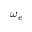Convert formula to latex. <formula><loc_0><loc_0><loc_500><loc_500>\omega _ { e }</formula> 